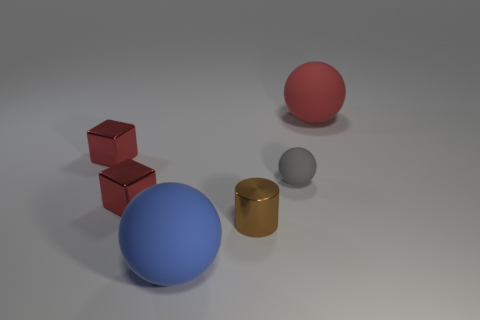Subtract 1 balls. How many balls are left? 2 Add 3 large yellow spheres. How many objects exist? 9 Subtract all blocks. How many objects are left? 4 Add 3 red matte things. How many red matte things are left? 4 Add 1 tiny cyan balls. How many tiny cyan balls exist? 1 Subtract 0 green cylinders. How many objects are left? 6 Subtract all big gray cubes. Subtract all tiny red cubes. How many objects are left? 4 